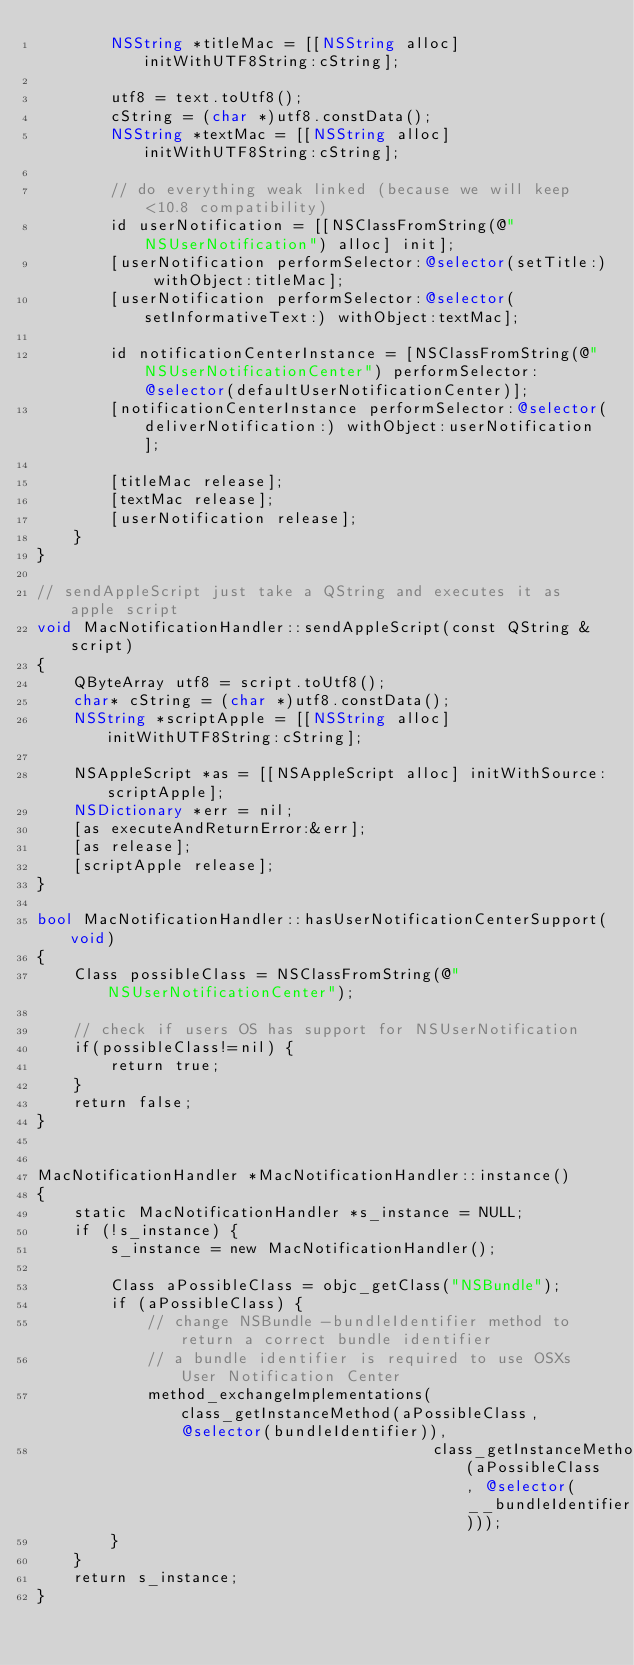<code> <loc_0><loc_0><loc_500><loc_500><_ObjectiveC_>        NSString *titleMac = [[NSString alloc] initWithUTF8String:cString];

        utf8 = text.toUtf8();
        cString = (char *)utf8.constData();
        NSString *textMac = [[NSString alloc] initWithUTF8String:cString];

        // do everything weak linked (because we will keep <10.8 compatibility)
        id userNotification = [[NSClassFromString(@"NSUserNotification") alloc] init];
        [userNotification performSelector:@selector(setTitle:) withObject:titleMac];
        [userNotification performSelector:@selector(setInformativeText:) withObject:textMac];

        id notificationCenterInstance = [NSClassFromString(@"NSUserNotificationCenter") performSelector:@selector(defaultUserNotificationCenter)];
        [notificationCenterInstance performSelector:@selector(deliverNotification:) withObject:userNotification];

        [titleMac release];
        [textMac release];
        [userNotification release];
    }
}

// sendAppleScript just take a QString and executes it as apple script
void MacNotificationHandler::sendAppleScript(const QString &script)
{
    QByteArray utf8 = script.toUtf8();
    char* cString = (char *)utf8.constData();
    NSString *scriptApple = [[NSString alloc] initWithUTF8String:cString];

    NSAppleScript *as = [[NSAppleScript alloc] initWithSource:scriptApple];
    NSDictionary *err = nil;
    [as executeAndReturnError:&err];
    [as release];
    [scriptApple release];
}

bool MacNotificationHandler::hasUserNotificationCenterSupport(void)
{
    Class possibleClass = NSClassFromString(@"NSUserNotificationCenter");

    // check if users OS has support for NSUserNotification
    if(possibleClass!=nil) {
        return true;
    }
    return false;
}


MacNotificationHandler *MacNotificationHandler::instance()
{
    static MacNotificationHandler *s_instance = NULL;
    if (!s_instance) {
        s_instance = new MacNotificationHandler();
        
        Class aPossibleClass = objc_getClass("NSBundle");
        if (aPossibleClass) {
            // change NSBundle -bundleIdentifier method to return a correct bundle identifier
            // a bundle identifier is required to use OSXs User Notification Center
            method_exchangeImplementations(class_getInstanceMethod(aPossibleClass, @selector(bundleIdentifier)),
                                           class_getInstanceMethod(aPossibleClass, @selector(__bundleIdentifier)));
        }
    }
    return s_instance;
}
</code> 